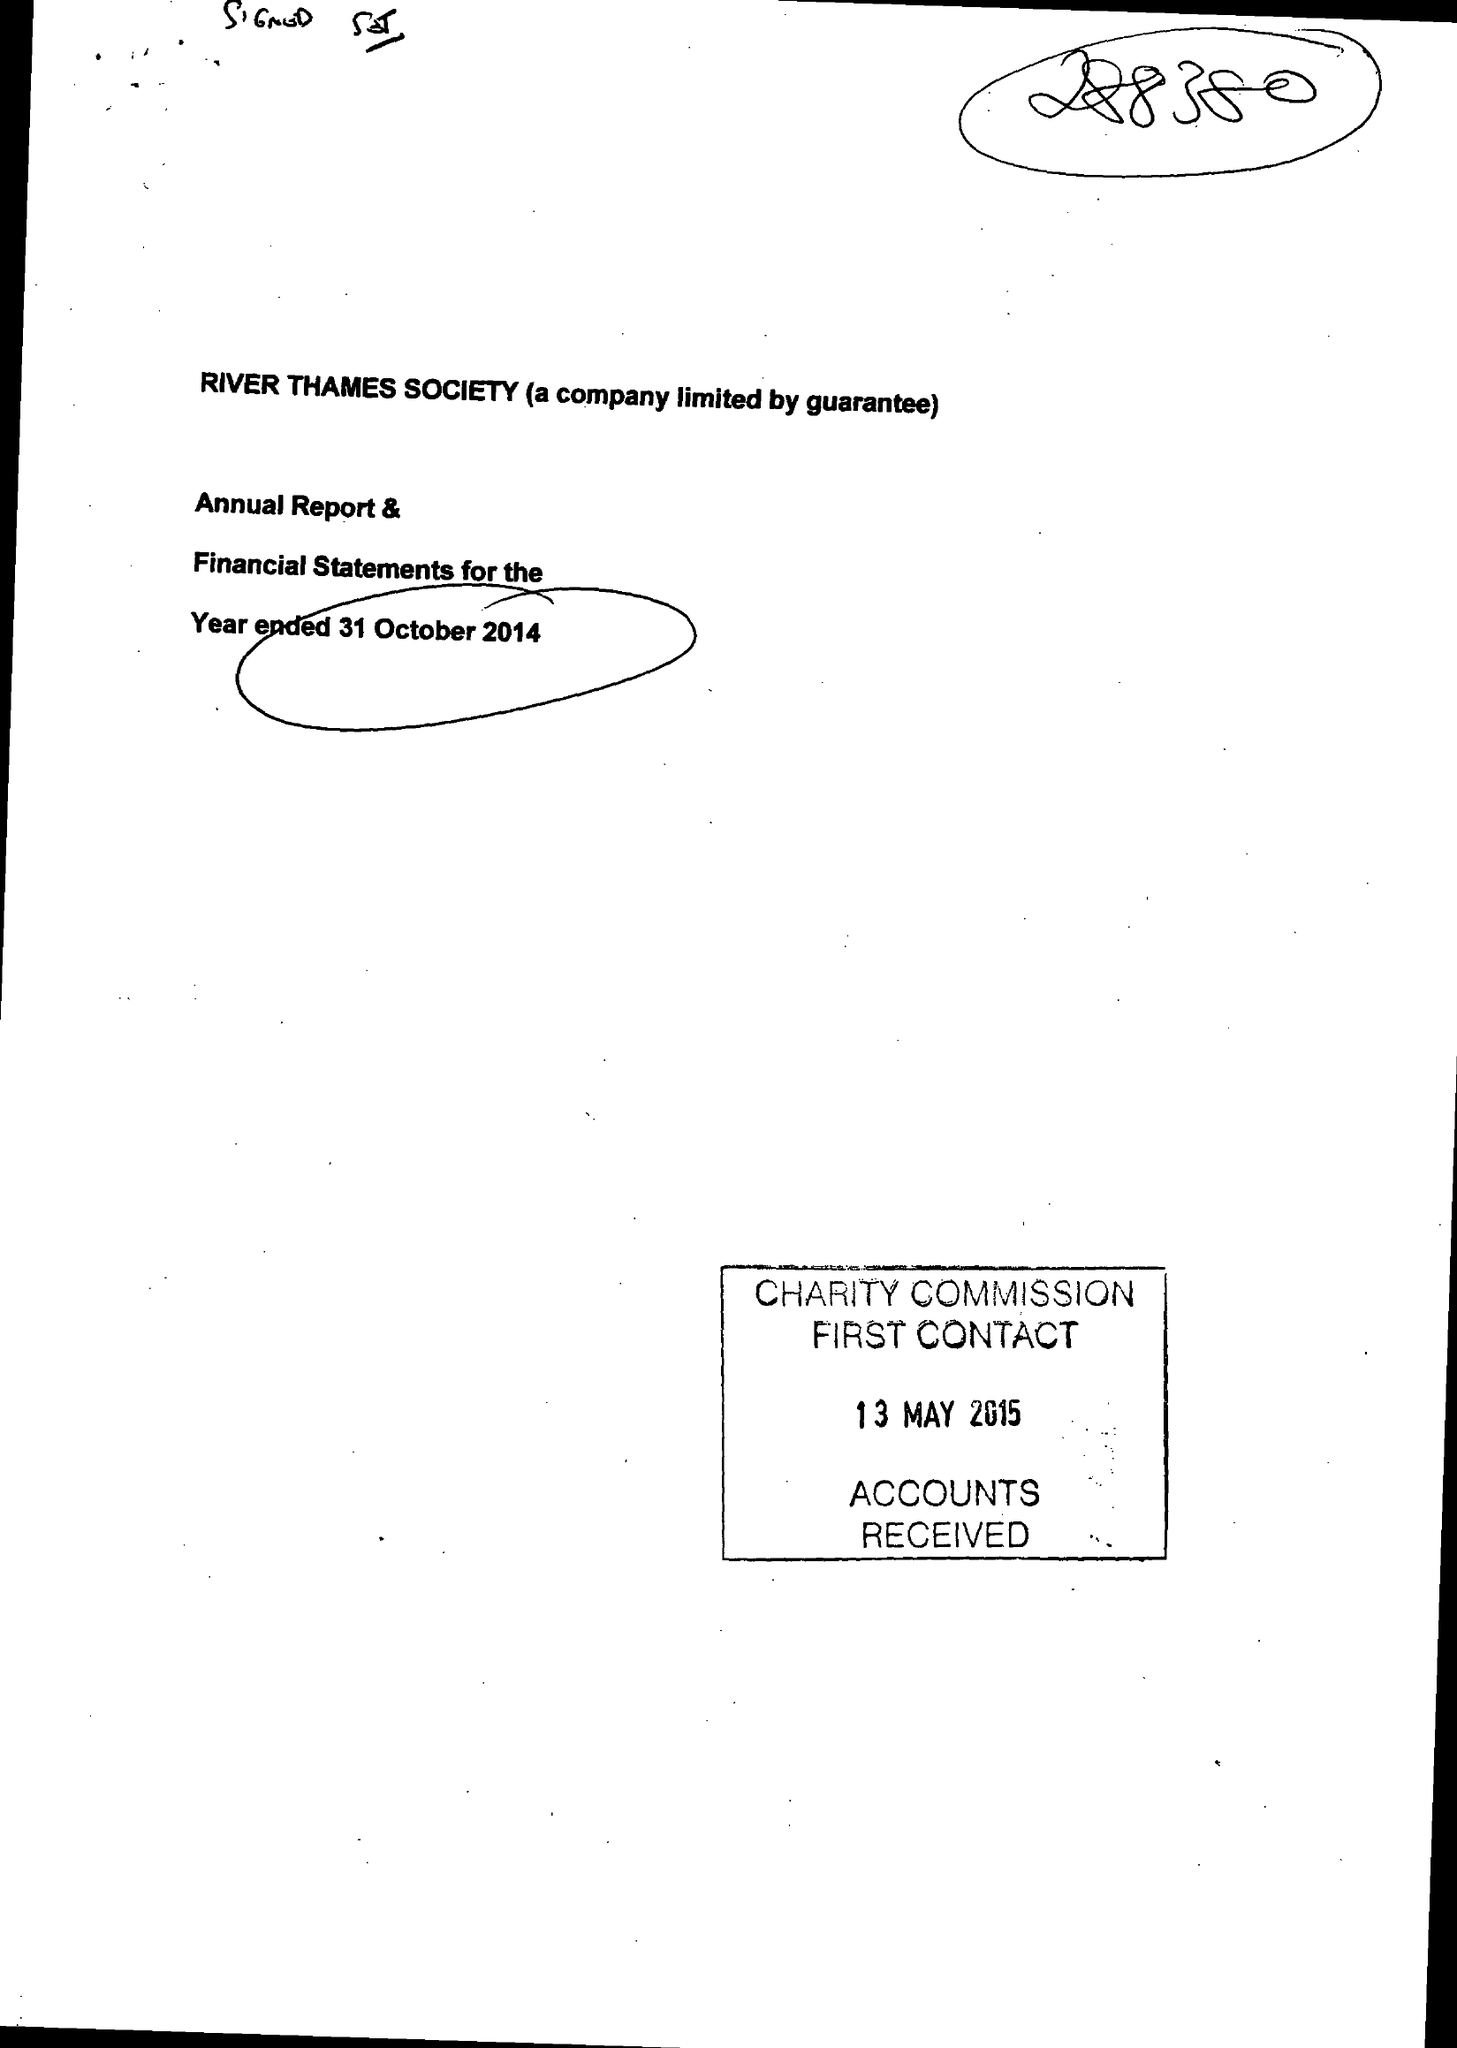What is the value for the income_annually_in_british_pounds?
Answer the question using a single word or phrase. 41976.00 